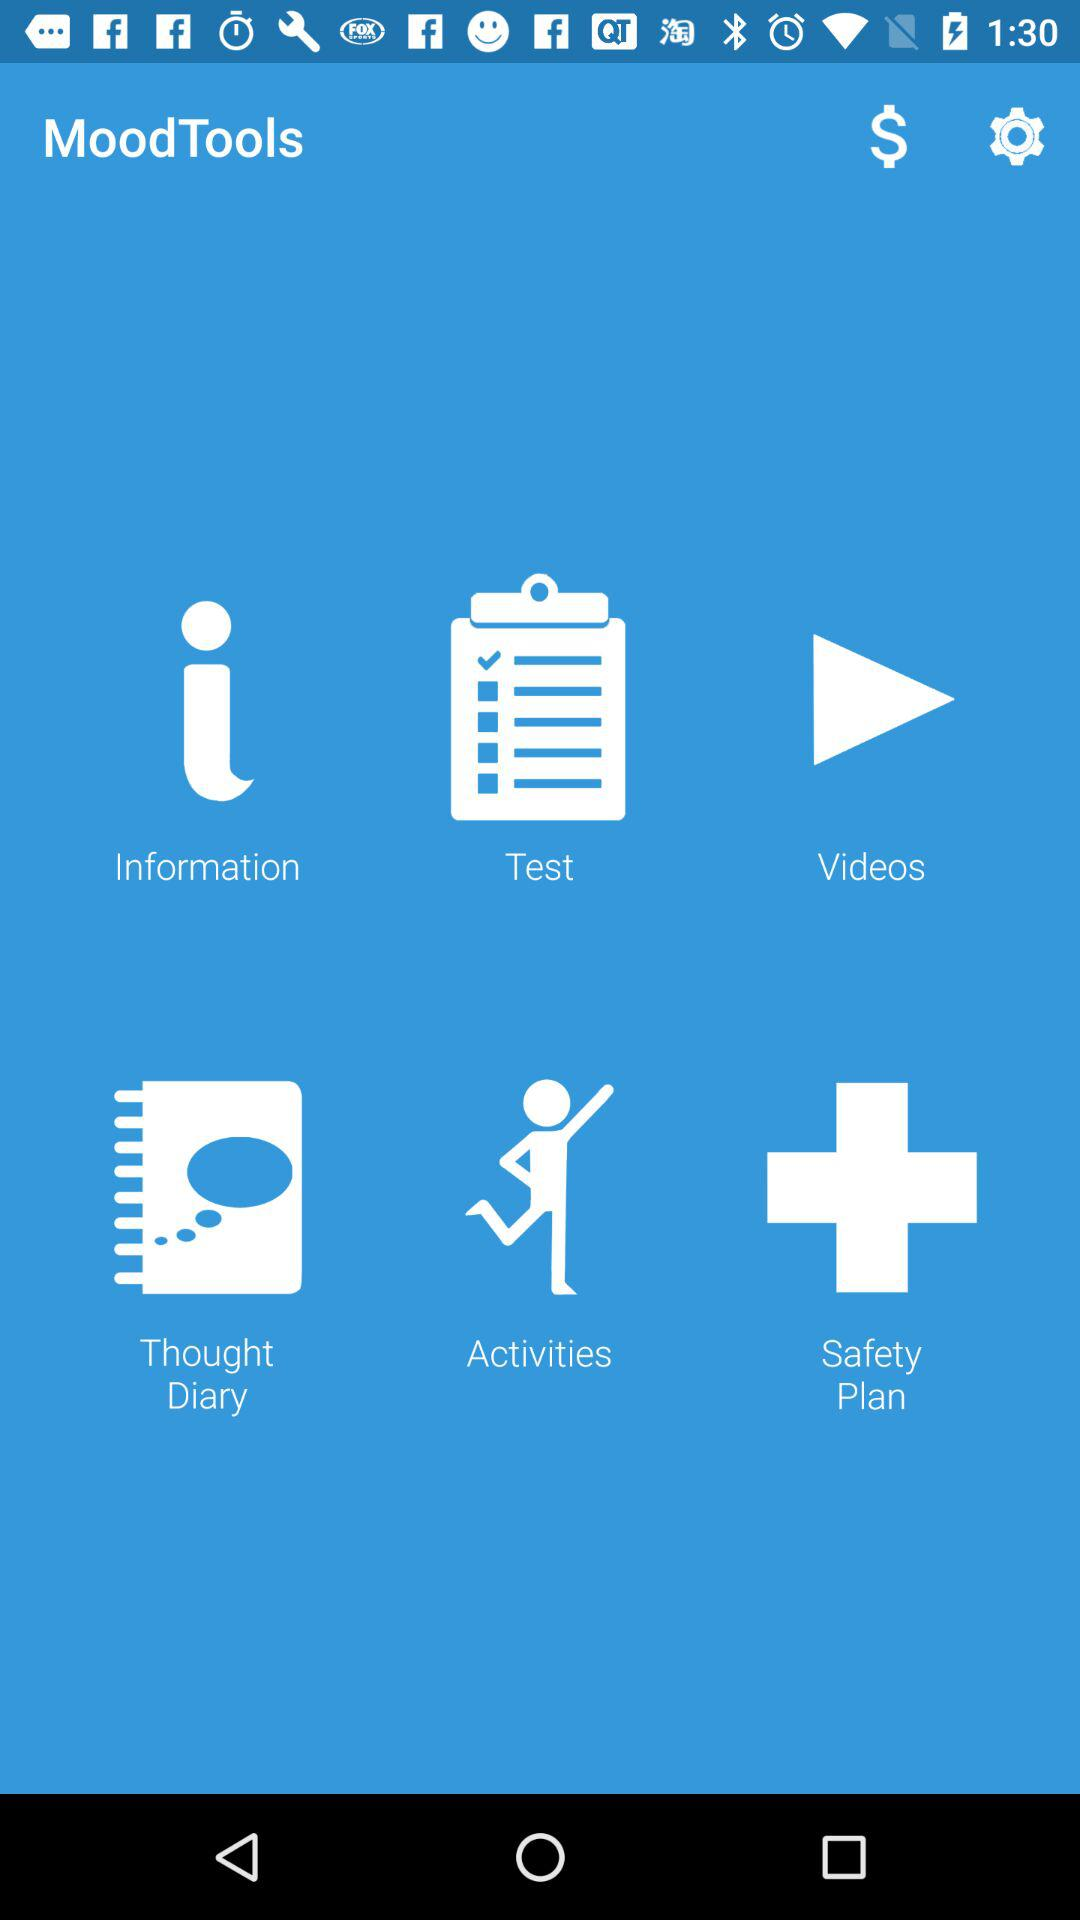What is the application name? The application name is "MoodTools". 